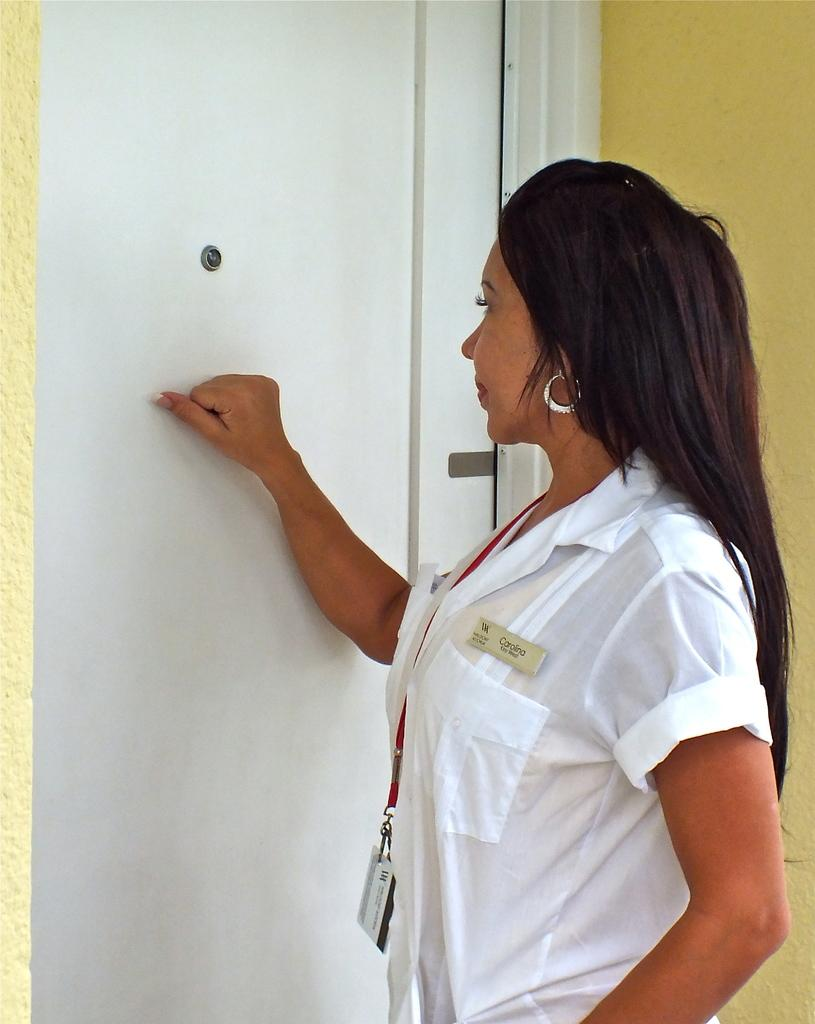What is the main subject of the image? There is a woman standing in the image. What is the woman wearing that is visible in the image? The woman is wearing a tag. What is in front of the woman in the image? There is a door in front of the woman. What can be seen behind the woman in the image? There is a wall in the background of the image. What type of frame is the woman standing inside of in the image? There is no frame present in the image; it is a photograph or image of the woman standing in a room or space. 